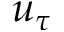<formula> <loc_0><loc_0><loc_500><loc_500>u _ { \tau }</formula> 